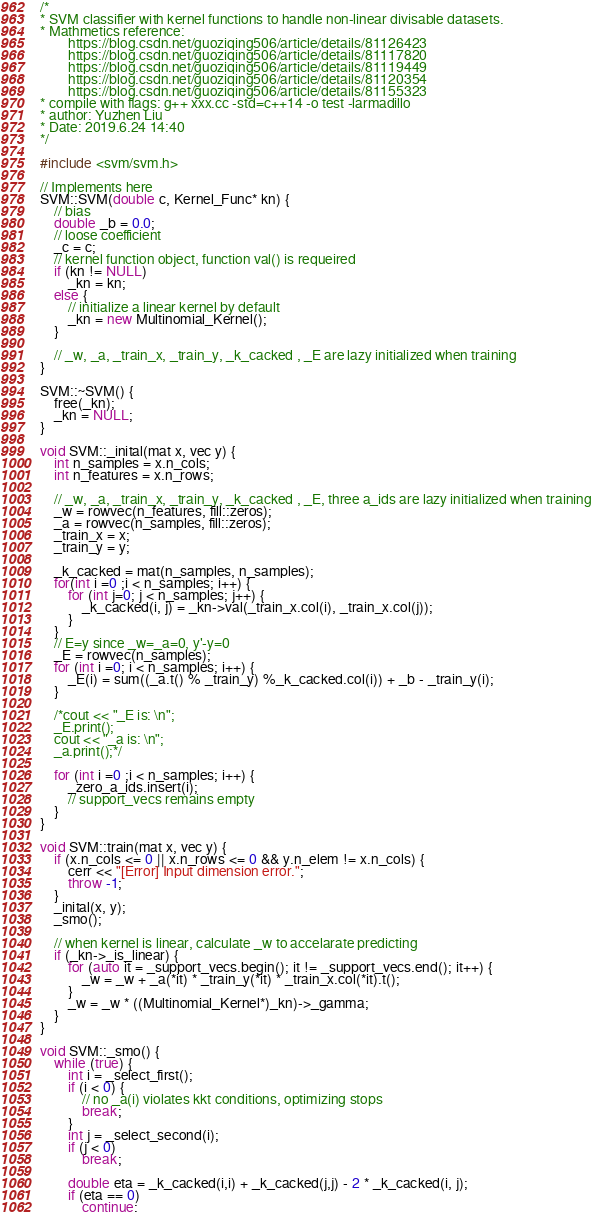Convert code to text. <code><loc_0><loc_0><loc_500><loc_500><_C++_>/*
* SVM classifier with kernel functions to handle non-linear divisable datasets.
* Mathmetics reference: 
        https://blog.csdn.net/guoziqing506/article/details/81126423
        https://blog.csdn.net/guoziqing506/article/details/81117820
        https://blog.csdn.net/guoziqing506/article/details/81119449
        https://blog.csdn.net/guoziqing506/article/details/81120354
        https://blog.csdn.net/guoziqing506/article/details/81155323
* compile with flags: g++ xxx.cc -std=c++14 -o test -larmadillo
* author: Yuzhen Liu
* Date: 2019.6.24 14:40
*/

#include <svm/svm.h>

// Implements here
SVM::SVM(double c, Kernel_Func* kn) {
    // bias
    double _b = 0.0; 
    // loose coefficient
    _c = c;
    // kernel function object, function val() is requeired
    if (kn != NULL)
        _kn = kn;  
    else {
        // initialize a linear kernel by default
        _kn = new Multinomial_Kernel();
    }

    // _w, _a, _train_x, _train_y, _k_cacked , _E are lazy initialized when training
}

SVM::~SVM() {
    free(_kn);
    _kn = NULL;
}

void SVM::_inital(mat x, vec y) {
    int n_samples = x.n_cols;
    int n_features = x.n_rows;

    // _w, _a, _train_x, _train_y, _k_cacked , _E, three a_ids are lazy initialized when training
    _w = rowvec(n_features, fill::zeros);
    _a = rowvec(n_samples, fill::zeros);
    _train_x = x;
    _train_y = y;

    _k_cacked = mat(n_samples, n_samples);
    for(int i =0 ;i < n_samples; i++) {
        for (int j=0; j < n_samples; j++) {
            _k_cacked(i, j) = _kn->val(_train_x.col(i), _train_x.col(j));
        }
    }
    // E=y since _w=_a=0, y'-y=0
    _E = rowvec(n_samples);
    for (int i =0; i < n_samples; i++) {
        _E(i) = sum((_a.t() % _train_y) %_k_cacked.col(i)) + _b - _train_y(i);
    }

    /*cout << "_E is: \n";
    _E.print();
    cout << "_a is: \n";
    _a.print();*/

    for (int i =0 ;i < n_samples; i++) {
        _zero_a_ids.insert(i);
        // support_vecs remains empty
    }
}

void SVM::train(mat x, vec y) {
    if (x.n_cols <= 0 || x.n_rows <= 0 && y.n_elem != x.n_cols) {
        cerr << "[Error] Input dimension error.";
        throw -1;
    }
    _inital(x, y);
    _smo();

    // when kernel is linear, calculate _w to accelarate predicting
    if (_kn->_is_linear) {
        for (auto it = _support_vecs.begin(); it != _support_vecs.end(); it++) {
            _w = _w + _a(*it) * _train_y(*it) * _train_x.col(*it).t();
        }
        _w = _w * ((Multinomial_Kernel*)_kn)->_gamma;
    }
}

void SVM::_smo() {
    while (true) {
        int i = _select_first();
        if (i < 0) {
            // no _a(i) violates kkt conditions, optimizing stops
            break;
        }
        int j = _select_second(i);
        if (j < 0) 
            break;

        double eta = _k_cacked(i,i) + _k_cacked(j,j) - 2 * _k_cacked(i, j);
        if (eta == 0)
            continue;</code> 